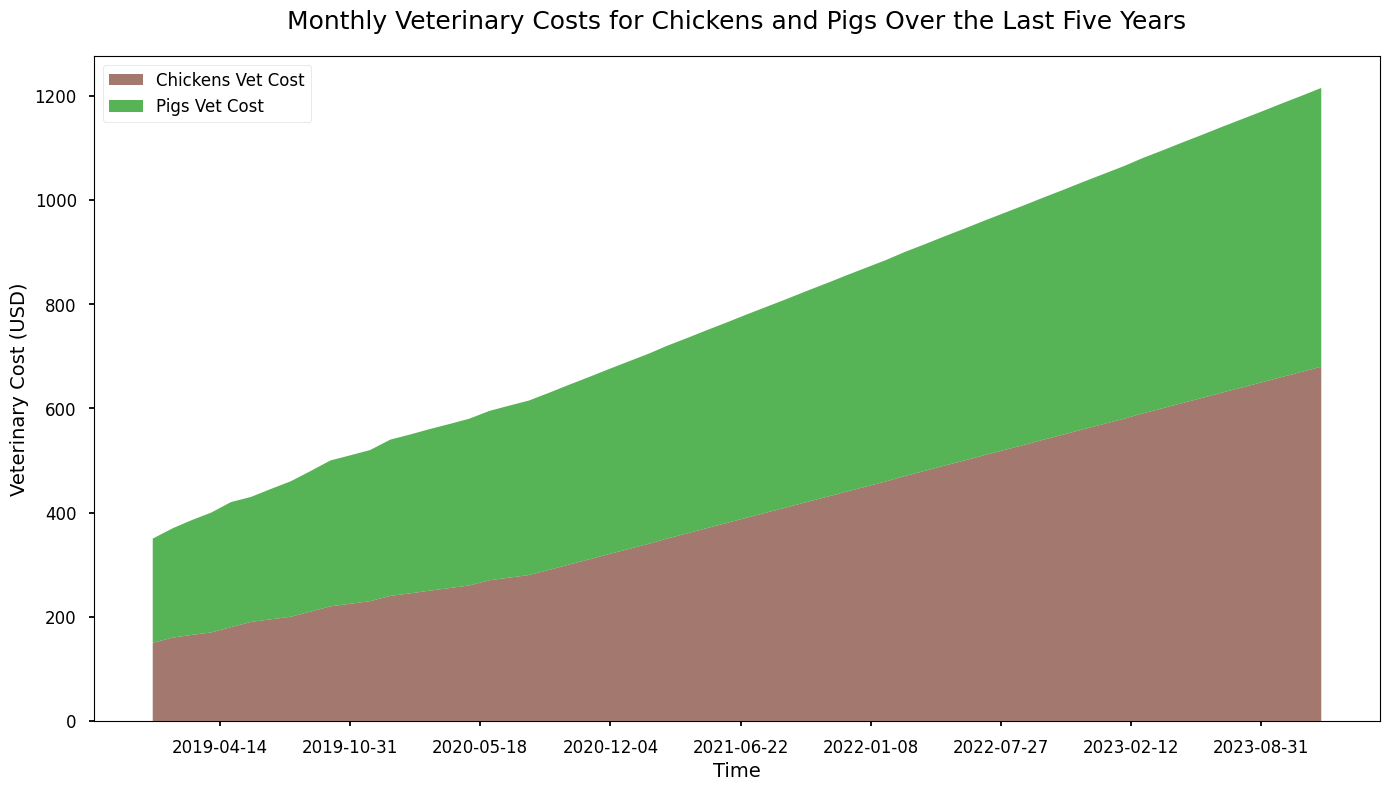What's the average veterinary cost for chickens in 2020? To find the average veterinary cost for chickens in 2020, locate the data points for chickens in 2020, sum them up, and divide by the number of months. The values are: (240 + 245 + 250 + 255 + 260 + 270 + 275 + 280 + 290 + 300 + 310 + 320). Add these values = 3,295, then divide by 12 months = 274.58.
Answer: 274.58 Which year had the highest total veterinary costs for pigs? Sum the monthly pig veterinary costs for each year and compare the totals. Compute the annual totals: 2019 = 3,160, 2020 = 3,955, 2021 = 4,560, 2022 = 5,580, 2023 = 5,970. The highest total is for 2023.
Answer: 2023 When did the veterinary costs for chickens first reach $500? Identify the month and year when the chickens' veterinary costs first equal or exceed $500. From the data, it occurs in June 2022.
Answer: June 2022 What is the visual difference in color between the area representing chickens and pigs costs? The chart uses different colors to visually distinguish between chickens and pigs' veterinary costs. The area representing chickens is colored in a brownish hue, while that for pigs is in a greenish hue.
Answer: brown and green By how much did the veterinary costs for pigs increase from the beginning to the end of the five-year period? Find the veterinary costs for pigs in January 2019 and December 2023, then calculate the difference. January 2019 = $200, December 2023 = $535, so the increase is $535 - $200 = $335.
Answer: $335 Which month historically has the highest veterinary costs for both chickens and pigs combined over the five years? Sum the combined veterinary costs for chickens and pigs for each month across all years, then determine which month has the highest value. December accumulates: 520+540+565+585+1215 = 3425.
Answer: December 